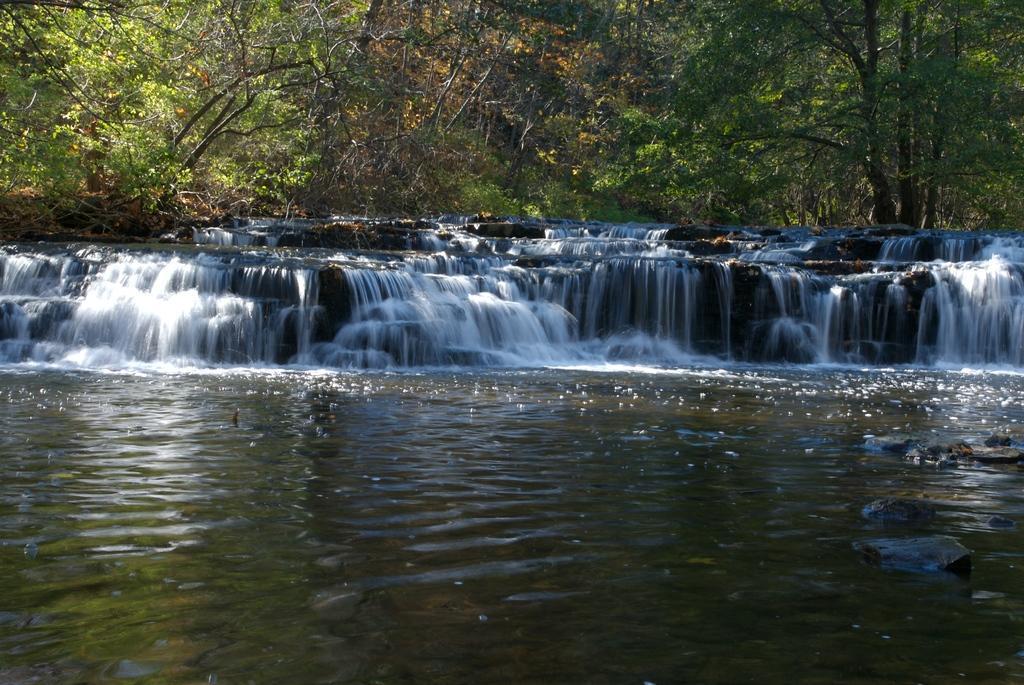Please provide a concise description of this image. In the foreground of the picture we can see waterfall and water body. In the background there are trees. 